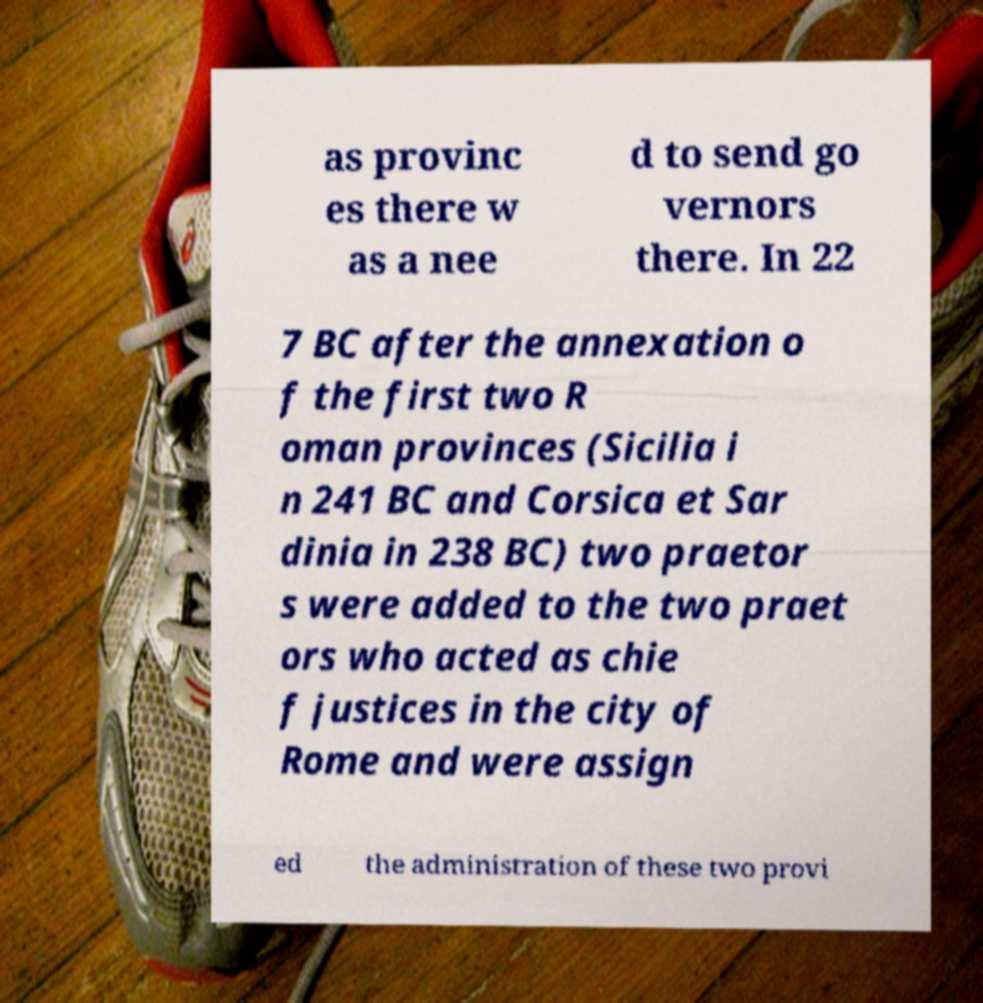Can you accurately transcribe the text from the provided image for me? as provinc es there w as a nee d to send go vernors there. In 22 7 BC after the annexation o f the first two R oman provinces (Sicilia i n 241 BC and Corsica et Sar dinia in 238 BC) two praetor s were added to the two praet ors who acted as chie f justices in the city of Rome and were assign ed the administration of these two provi 